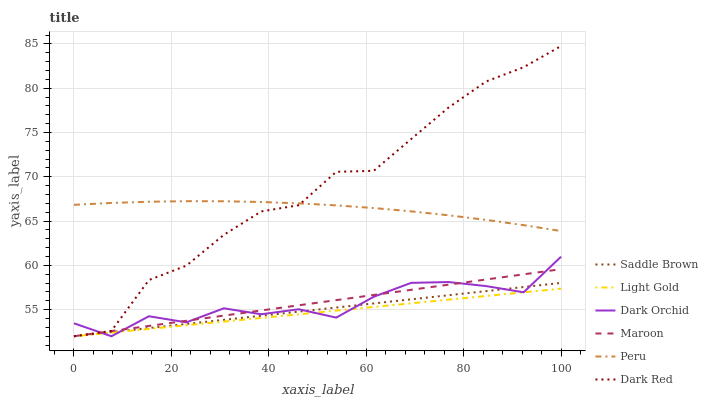Does Light Gold have the minimum area under the curve?
Answer yes or no. Yes. Does Dark Red have the maximum area under the curve?
Answer yes or no. Yes. Does Maroon have the minimum area under the curve?
Answer yes or no. No. Does Maroon have the maximum area under the curve?
Answer yes or no. No. Is Maroon the smoothest?
Answer yes or no. Yes. Is Dark Red the roughest?
Answer yes or no. Yes. Is Dark Orchid the smoothest?
Answer yes or no. No. Is Dark Orchid the roughest?
Answer yes or no. No. Does Peru have the lowest value?
Answer yes or no. No. Does Dark Red have the highest value?
Answer yes or no. Yes. Does Maroon have the highest value?
Answer yes or no. No. Is Maroon less than Peru?
Answer yes or no. Yes. Is Peru greater than Light Gold?
Answer yes or no. Yes. Does Dark Orchid intersect Light Gold?
Answer yes or no. Yes. Is Dark Orchid less than Light Gold?
Answer yes or no. No. Is Dark Orchid greater than Light Gold?
Answer yes or no. No. Does Maroon intersect Peru?
Answer yes or no. No. 